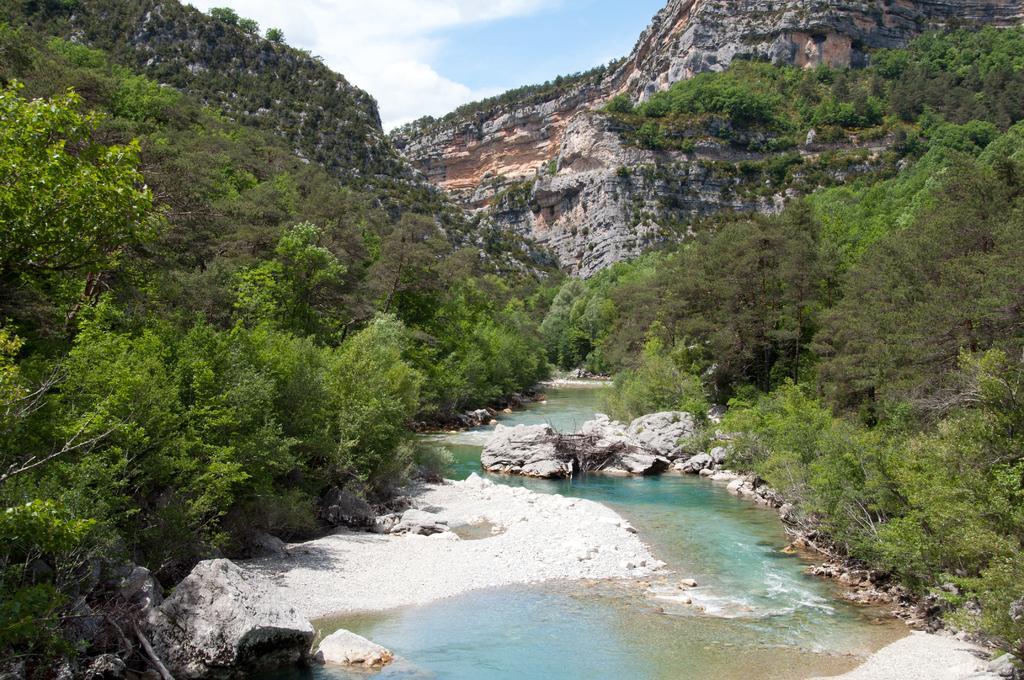Can you describe this image briefly? In this picture there is water in the center of the image and there are trees on the right and left side of the image and there are rocks in the center of the image. 